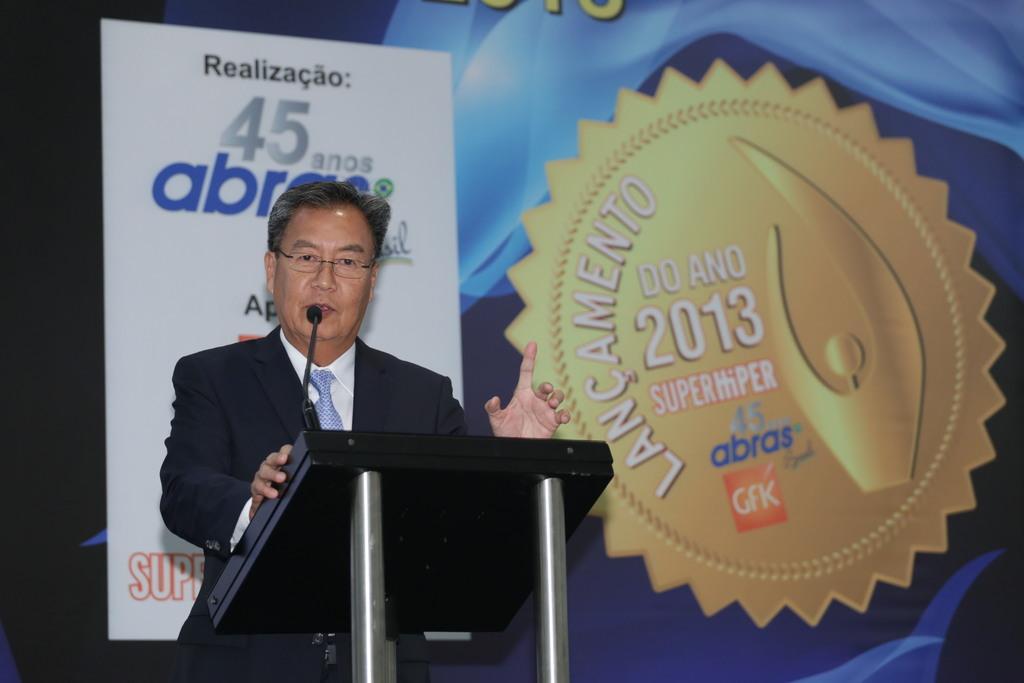Please provide a concise description of this image. In the image we can see a man standing, wearing clothes, spectacles and it looks like he is talking. Here we can see the podium and microphone, behind him we can see the poster and text on the poster. 